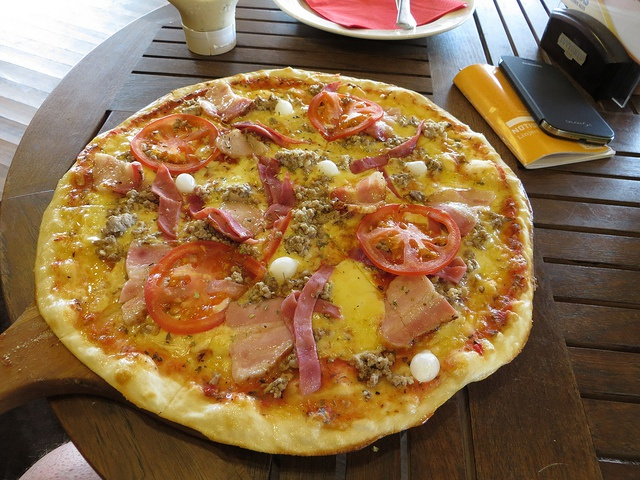Describe the objects in this image and their specific colors. I can see pizza in white, brown, olive, and tan tones, book in white, orange, olive, and tan tones, cell phone in white, black, blue, and darkblue tones, and spoon in white, darkgray, and gray tones in this image. 